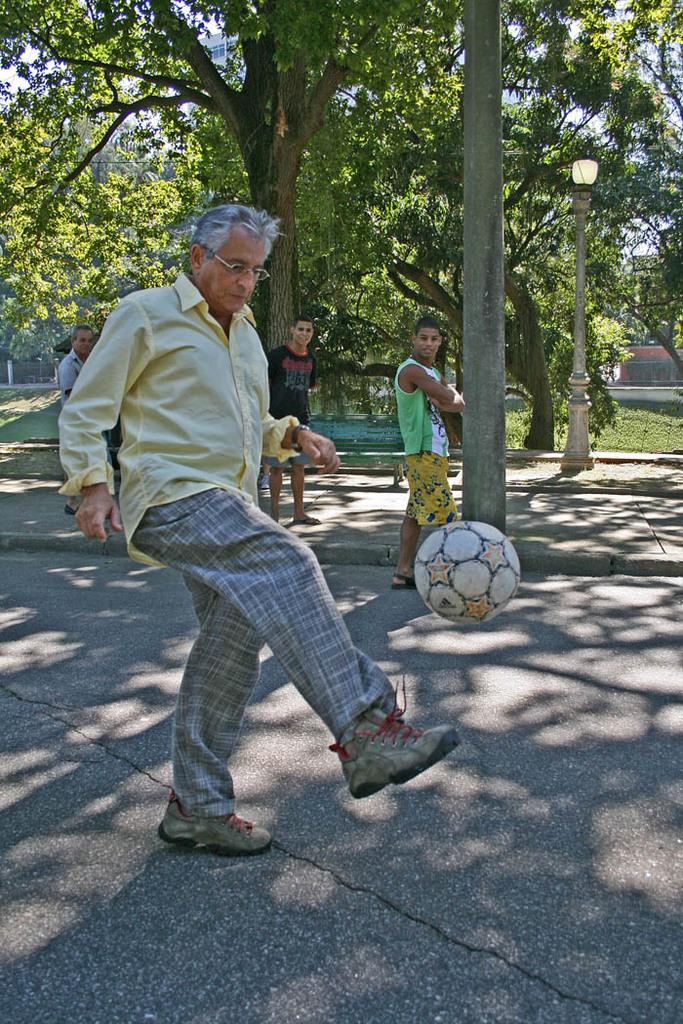What is the person in the image wearing? The person in the image is wearing a yellow shirt. What activity is the person in the yellow shirt engaged in? The person is playing with a ball. Are there any other people present in the image? Yes, there are people standing beside the person playing with the ball. What can be seen in the background of the image? There are trees in the background of the image. Can you see a frog jumping out of the person's pocket in the image? No, there is no frog or pocket visible in the image. Is the person in the yellow shirt taking a bath in the image? No, the person in the yellow shirt is playing with a ball, not taking a bath. 